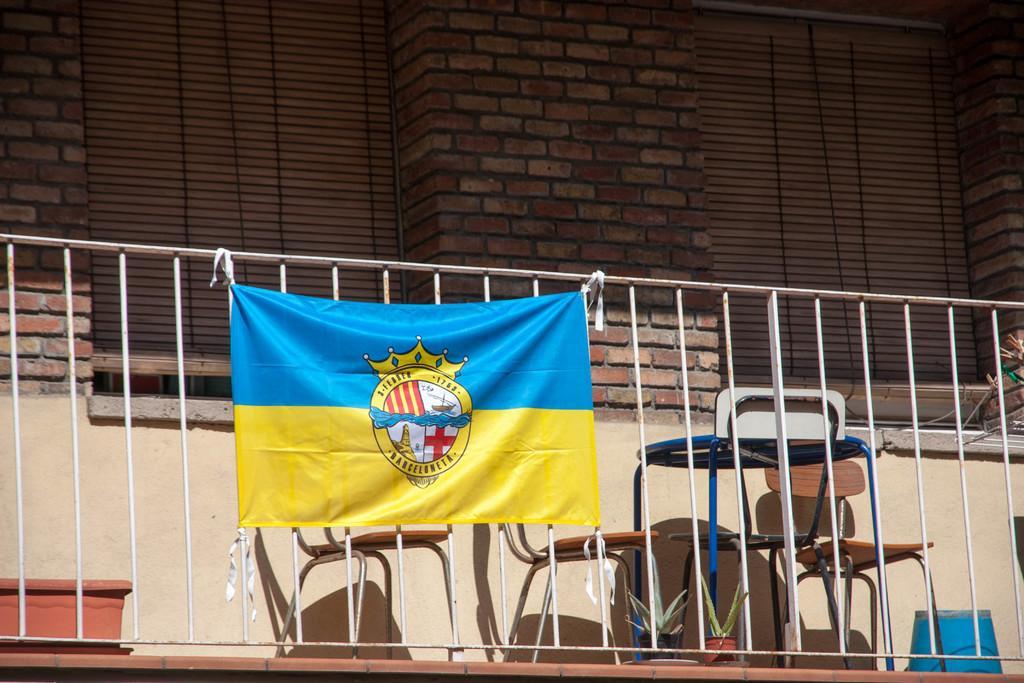Please provide a concise description of this image. In this image I can see a banner tied to the railing. Behind that there is a building with red bricks and window blind. There are some chairs and flower pots. 